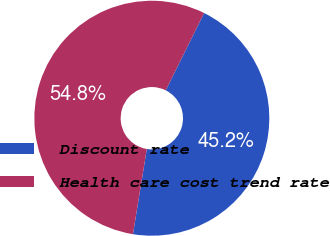Convert chart to OTSL. <chart><loc_0><loc_0><loc_500><loc_500><pie_chart><fcel>Discount rate<fcel>Health care cost trend rate<nl><fcel>45.23%<fcel>54.77%<nl></chart> 